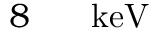<formula> <loc_0><loc_0><loc_500><loc_500>8 { { \, } } { k e V }</formula> 